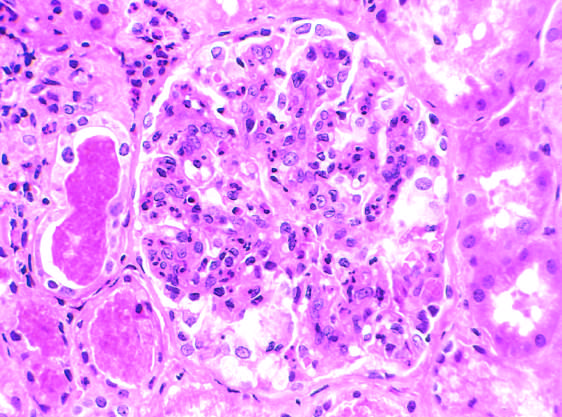what is glomerular hypercellularity caused by?
Answer the question using a single word or phrase. Intracapillary leukocytes and proliferation of intrinsic glomerular cells 